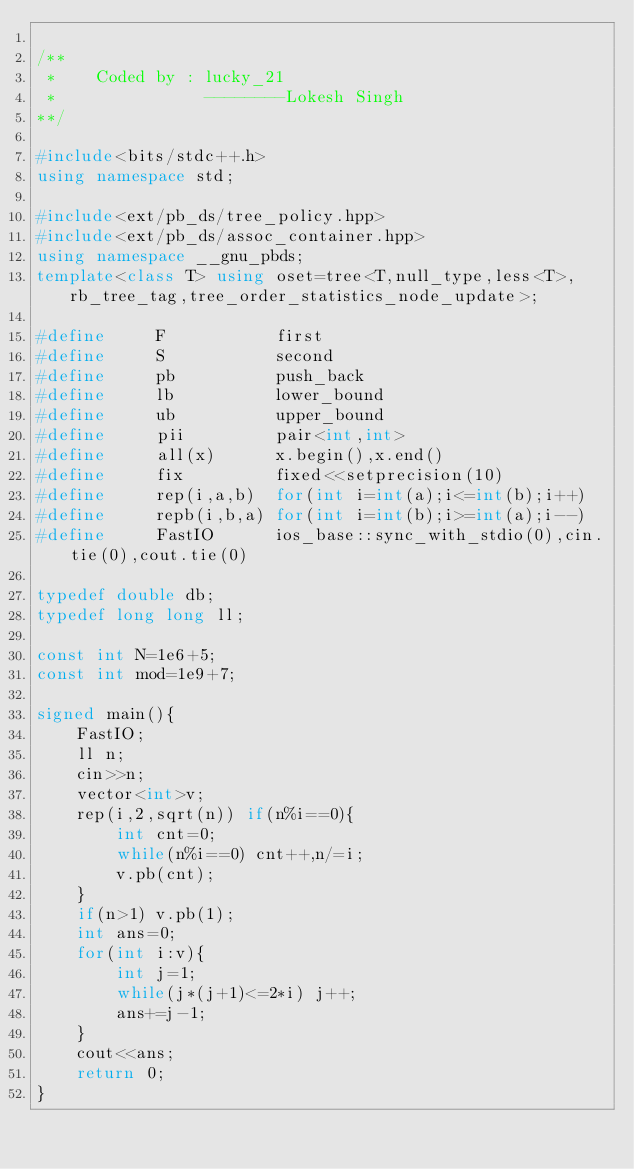Convert code to text. <code><loc_0><loc_0><loc_500><loc_500><_C++_>
/**
 *    Coded by : lucky_21
 *               --------Lokesh Singh
**/

#include<bits/stdc++.h>
using namespace std;

#include<ext/pb_ds/tree_policy.hpp>
#include<ext/pb_ds/assoc_container.hpp>
using namespace __gnu_pbds;
template<class T> using oset=tree<T,null_type,less<T>,rb_tree_tag,tree_order_statistics_node_update>;

#define     F           first
#define     S           second
#define     pb          push_back
#define     lb          lower_bound
#define     ub          upper_bound
#define     pii         pair<int,int>
#define     all(x)      x.begin(),x.end()
#define     fix         fixed<<setprecision(10)
#define     rep(i,a,b)  for(int i=int(a);i<=int(b);i++)
#define     repb(i,b,a) for(int i=int(b);i>=int(a);i--)
#define     FastIO      ios_base::sync_with_stdio(0),cin.tie(0),cout.tie(0)

typedef double db;
typedef long long ll;

const int N=1e6+5;
const int mod=1e9+7;

signed main(){
    FastIO;
    ll n;
    cin>>n;
    vector<int>v;
    rep(i,2,sqrt(n)) if(n%i==0){
        int cnt=0;
        while(n%i==0) cnt++,n/=i;
        v.pb(cnt);
    }
    if(n>1) v.pb(1);
    int ans=0;
    for(int i:v){
        int j=1;
        while(j*(j+1)<=2*i) j++;
        ans+=j-1;
    }
    cout<<ans;
    return 0;
}
</code> 